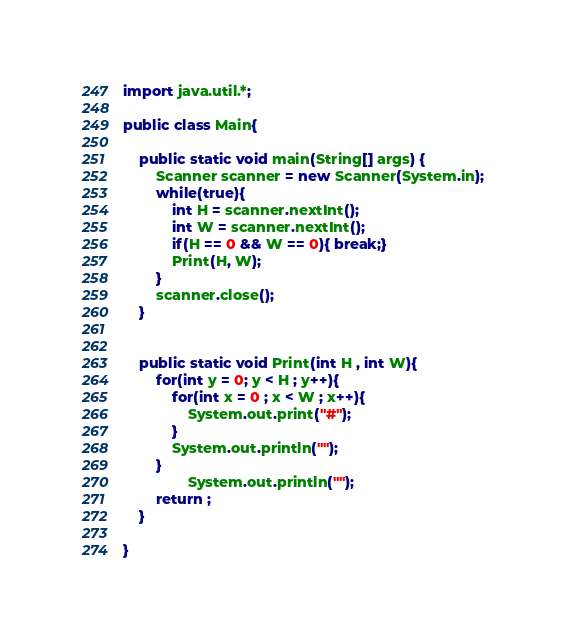Convert code to text. <code><loc_0><loc_0><loc_500><loc_500><_Java_>import java.util.*;

public class Main{

	public static void main(String[] args) {
		Scanner scanner = new Scanner(System.in);
		while(true){
			int H = scanner.nextInt();
			int W = scanner.nextInt();
			if(H == 0 && W == 0){ break;}
			Print(H, W);
		}
		scanner.close();
	}
	
	
	public static void Print(int H , int W){
		for(int y = 0; y < H ; y++){
			for(int x = 0 ; x < W ; x++){
				System.out.print("#");
			}
			System.out.println("");
		}
                System.out.println("");
		return ;
	}

}</code> 